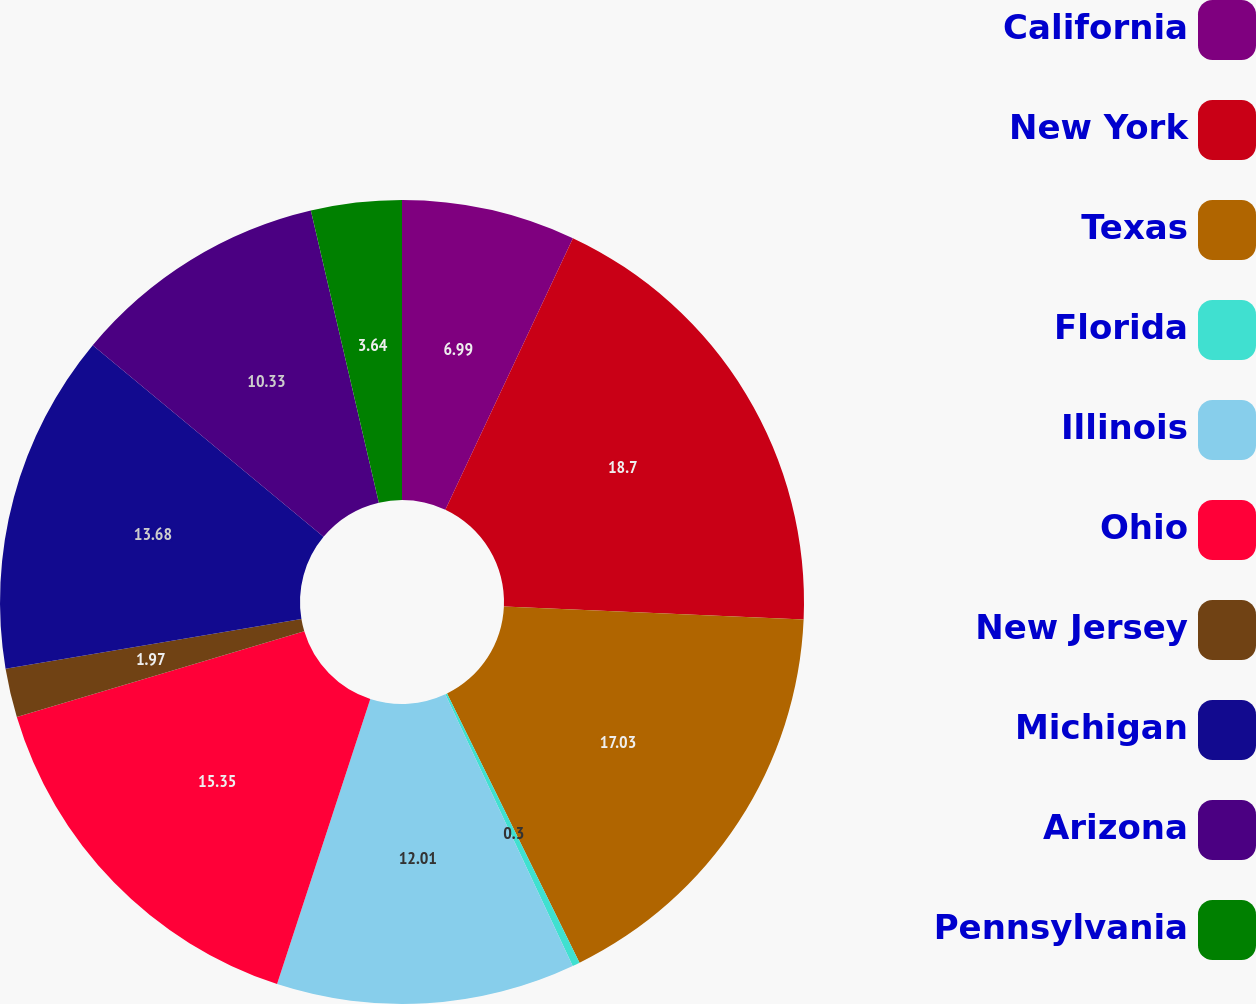Convert chart. <chart><loc_0><loc_0><loc_500><loc_500><pie_chart><fcel>California<fcel>New York<fcel>Texas<fcel>Florida<fcel>Illinois<fcel>Ohio<fcel>New Jersey<fcel>Michigan<fcel>Arizona<fcel>Pennsylvania<nl><fcel>6.99%<fcel>18.7%<fcel>17.03%<fcel>0.3%<fcel>12.01%<fcel>15.35%<fcel>1.97%<fcel>13.68%<fcel>10.33%<fcel>3.64%<nl></chart> 